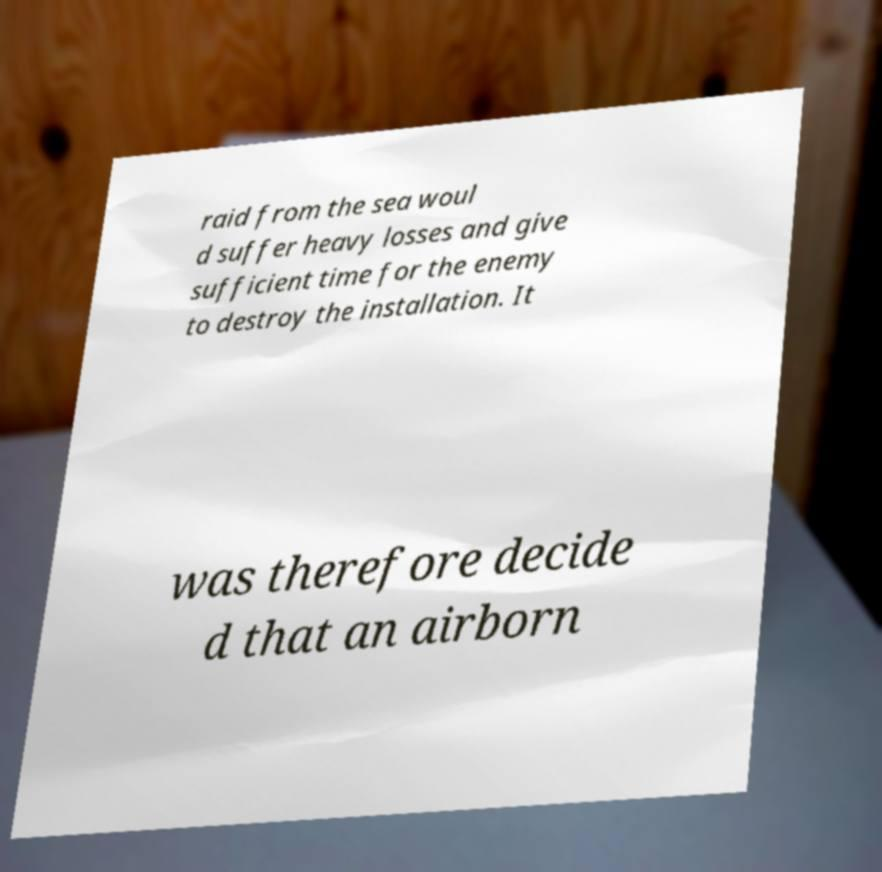Can you accurately transcribe the text from the provided image for me? raid from the sea woul d suffer heavy losses and give sufficient time for the enemy to destroy the installation. It was therefore decide d that an airborn 